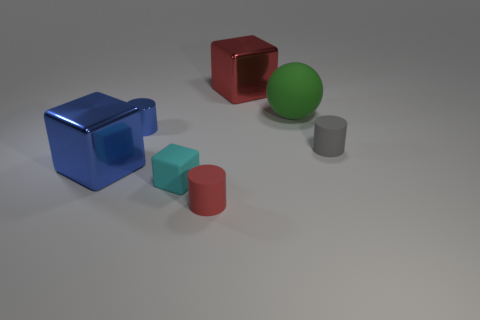What is the shape of the object that is the same color as the metal cylinder?
Give a very brief answer. Cube. Is the number of matte things that are in front of the red rubber cylinder the same as the number of cyan rubber objects that are behind the large blue metallic block?
Provide a succinct answer. Yes. How many other things are the same size as the cyan block?
Offer a terse response. 3. How big is the cyan object?
Your response must be concise. Small. Do the small gray object and the cube that is to the right of the red matte cylinder have the same material?
Offer a very short reply. No. Is there a red metallic object of the same shape as the small gray object?
Offer a terse response. No. There is another cube that is the same size as the red block; what is it made of?
Provide a succinct answer. Metal. There is a rubber object in front of the tiny cube; what size is it?
Offer a terse response. Small. Is the size of the red thing in front of the red block the same as the blue metal object behind the small gray cylinder?
Make the answer very short. Yes. How many purple cylinders are the same material as the cyan thing?
Provide a succinct answer. 0. 